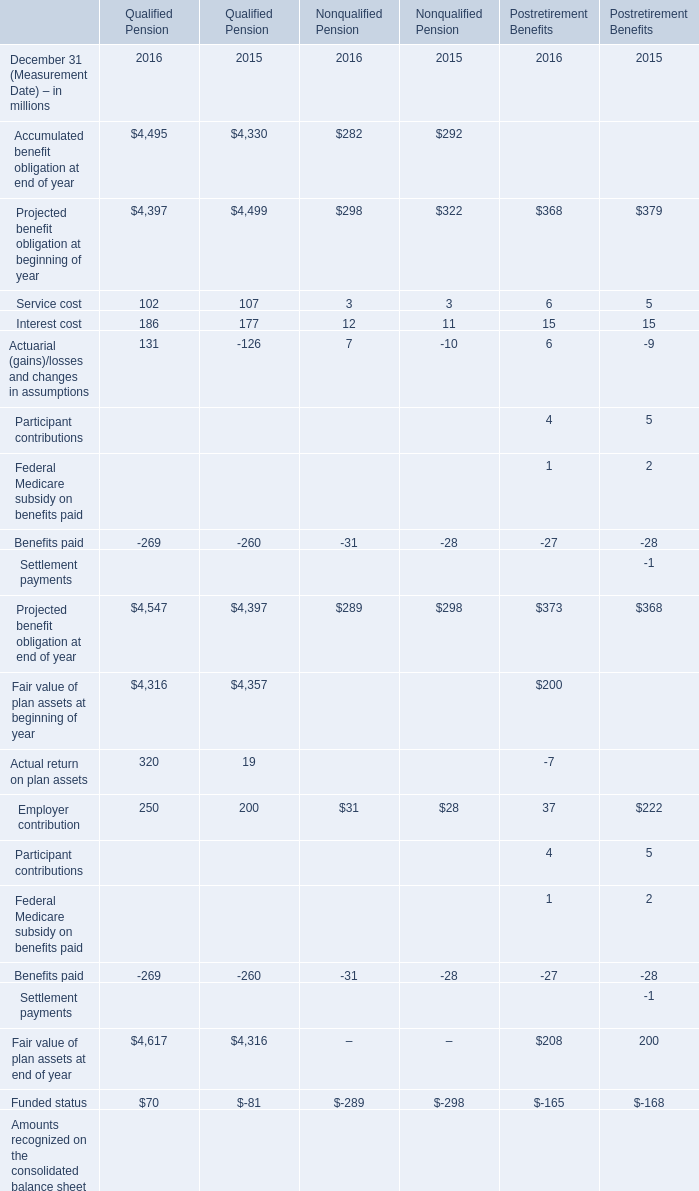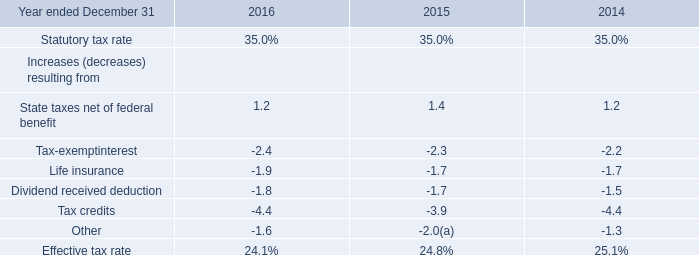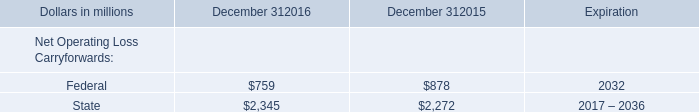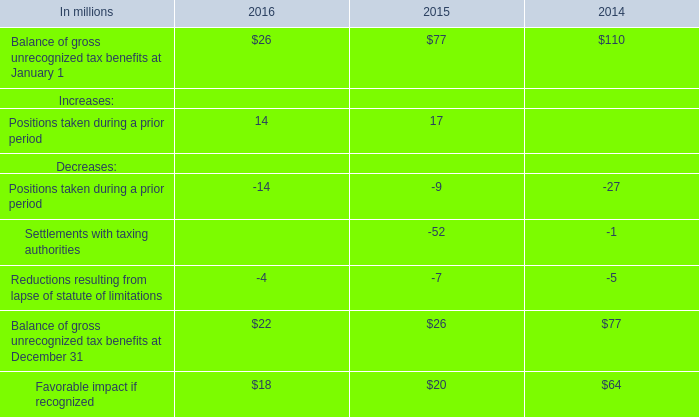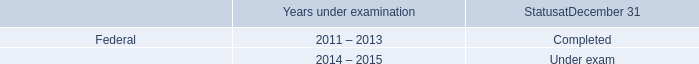Which year is Projected benefit obligation at end of year for Nonqualified Pension on December 31 higher? 
Answer: 2015. 